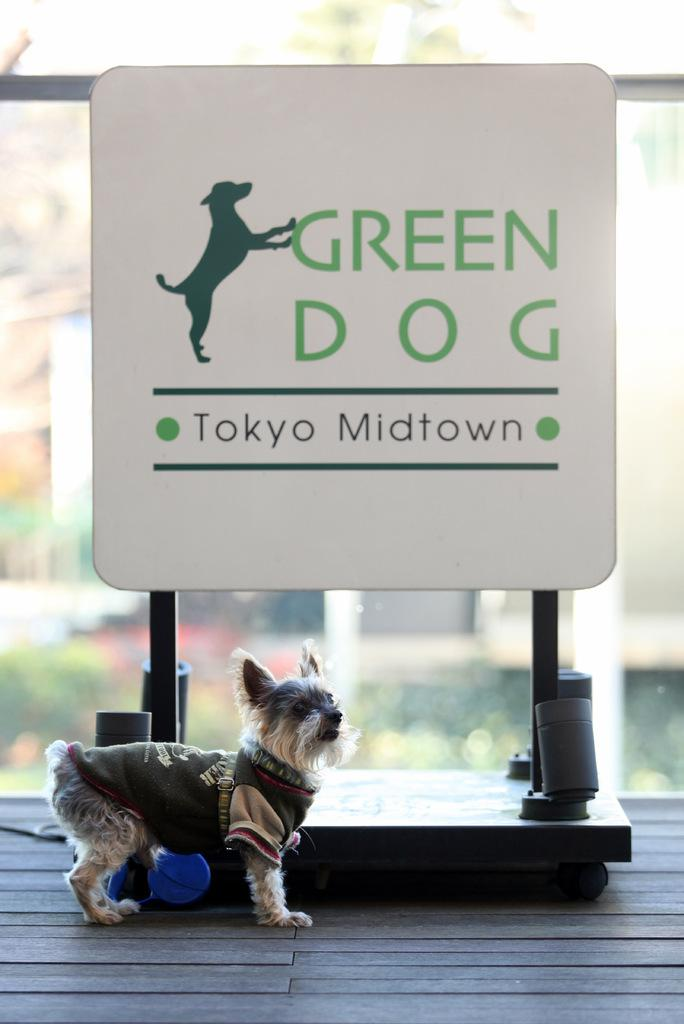What type of animal is in the image? There is a dog in the image. Where is the dog located in the image? The dog is standing on the floor. What is behind the dog in the image? There is a board with names and a dog image behind the dog. Can you describe any other objects or elements in the background of the image? There is a glass visible in the background of the image. How many units of centimeters does the dog's knowledge of quantum physics increase after the thunderstorm? There is no information about the dog's knowledge of quantum physics or any thunderstorm in the image, so this cannot be determined. 